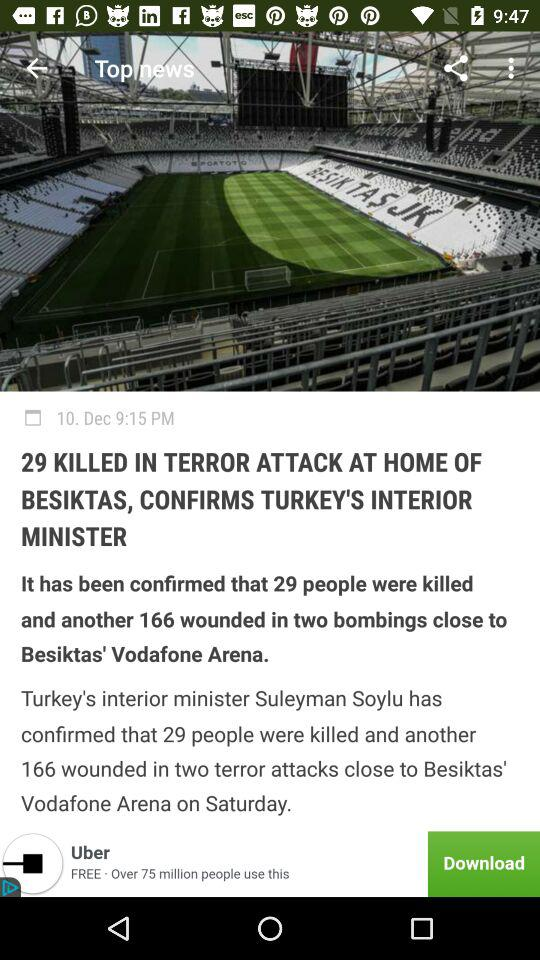What is the headline? The headline is "29 KILLED IN TERROR ATTACK AT HOME OF BESIKTAS, CONFIRMS TURKEY'S INTERIOR MINISTER". 